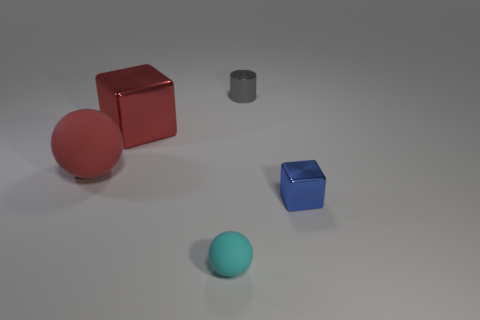Add 2 yellow cubes. How many objects exist? 7 Subtract all cylinders. How many objects are left? 4 Subtract all purple balls. Subtract all red shiny cubes. How many objects are left? 4 Add 1 metal cylinders. How many metal cylinders are left? 2 Add 1 green rubber cylinders. How many green rubber cylinders exist? 1 Subtract 0 gray cubes. How many objects are left? 5 